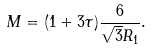<formula> <loc_0><loc_0><loc_500><loc_500>M = ( 1 + 3 \tau ) \frac { 6 } { \sqrt { 3 } R _ { 1 } } .</formula> 